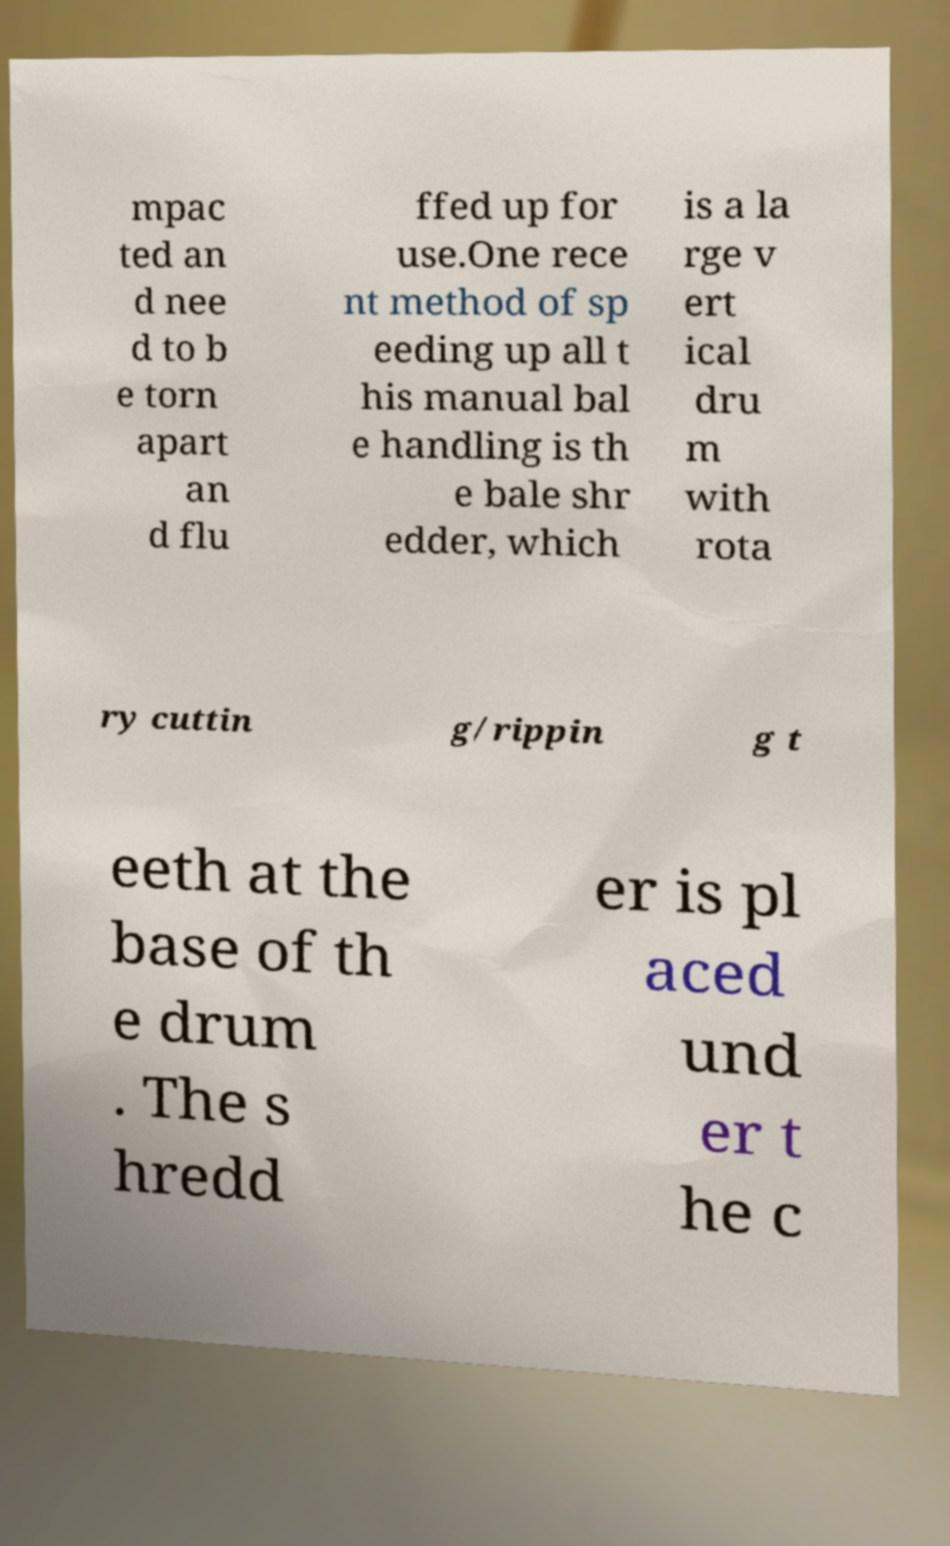I need the written content from this picture converted into text. Can you do that? mpac ted an d nee d to b e torn apart an d flu ffed up for use.One rece nt method of sp eeding up all t his manual bal e handling is th e bale shr edder, which is a la rge v ert ical dru m with rota ry cuttin g/rippin g t eeth at the base of th e drum . The s hredd er is pl aced und er t he c 